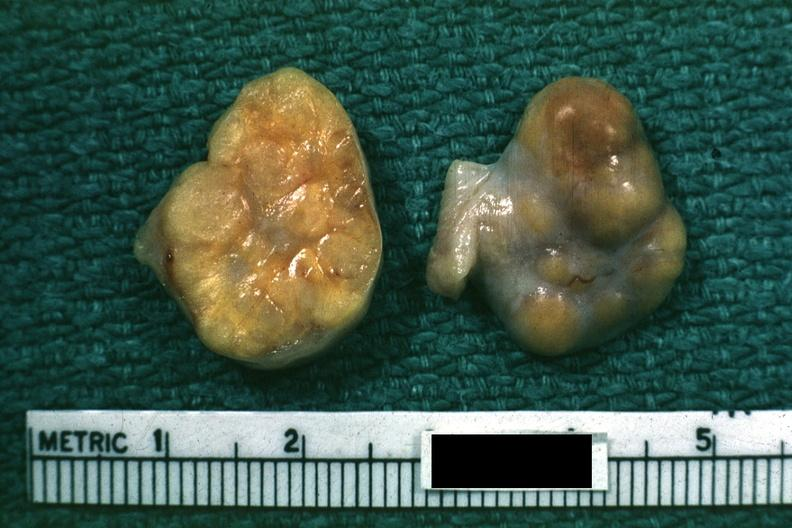what does yellow color indicate?
Answer the question using a single word or phrase. Theca cells can not recognize as ovary 